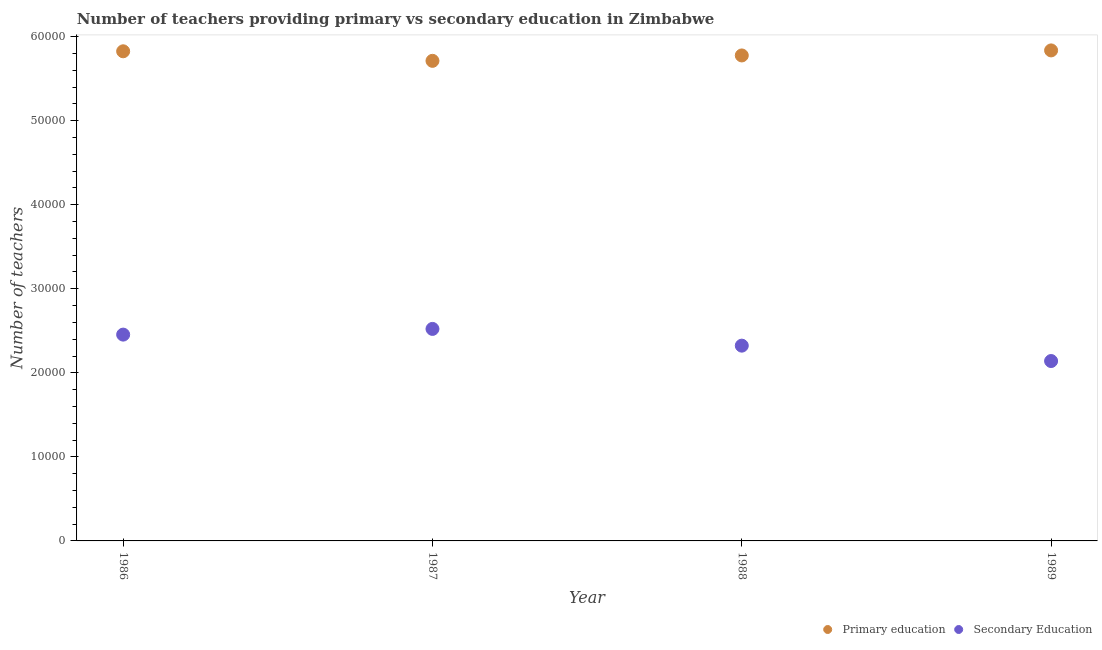How many different coloured dotlines are there?
Offer a terse response. 2. What is the number of primary teachers in 1988?
Keep it short and to the point. 5.78e+04. Across all years, what is the maximum number of secondary teachers?
Provide a short and direct response. 2.52e+04. Across all years, what is the minimum number of primary teachers?
Give a very brief answer. 5.71e+04. What is the total number of secondary teachers in the graph?
Make the answer very short. 9.44e+04. What is the difference between the number of secondary teachers in 1988 and the number of primary teachers in 1986?
Ensure brevity in your answer.  -3.50e+04. What is the average number of primary teachers per year?
Ensure brevity in your answer.  5.79e+04. In the year 1988, what is the difference between the number of primary teachers and number of secondary teachers?
Keep it short and to the point. 3.45e+04. What is the ratio of the number of secondary teachers in 1987 to that in 1988?
Provide a succinct answer. 1.09. What is the difference between the highest and the second highest number of secondary teachers?
Ensure brevity in your answer.  678. What is the difference between the highest and the lowest number of primary teachers?
Your answer should be very brief. 1242. Is the number of secondary teachers strictly less than the number of primary teachers over the years?
Provide a succinct answer. Yes. How many dotlines are there?
Provide a short and direct response. 2. How many years are there in the graph?
Your answer should be compact. 4. What is the difference between two consecutive major ticks on the Y-axis?
Provide a short and direct response. 10000. Does the graph contain grids?
Your response must be concise. No. Where does the legend appear in the graph?
Your answer should be very brief. Bottom right. How are the legend labels stacked?
Provide a short and direct response. Horizontal. What is the title of the graph?
Keep it short and to the point. Number of teachers providing primary vs secondary education in Zimbabwe. What is the label or title of the Y-axis?
Make the answer very short. Number of teachers. What is the Number of teachers in Primary education in 1986?
Offer a terse response. 5.83e+04. What is the Number of teachers in Secondary Education in 1986?
Keep it short and to the point. 2.45e+04. What is the Number of teachers in Primary education in 1987?
Your answer should be compact. 5.71e+04. What is the Number of teachers of Secondary Education in 1987?
Offer a terse response. 2.52e+04. What is the Number of teachers in Primary education in 1988?
Offer a terse response. 5.78e+04. What is the Number of teachers in Secondary Education in 1988?
Provide a succinct answer. 2.32e+04. What is the Number of teachers in Primary education in 1989?
Provide a succinct answer. 5.84e+04. What is the Number of teachers of Secondary Education in 1989?
Provide a succinct answer. 2.14e+04. Across all years, what is the maximum Number of teachers in Primary education?
Your answer should be very brief. 5.84e+04. Across all years, what is the maximum Number of teachers in Secondary Education?
Offer a terse response. 2.52e+04. Across all years, what is the minimum Number of teachers of Primary education?
Ensure brevity in your answer.  5.71e+04. Across all years, what is the minimum Number of teachers of Secondary Education?
Give a very brief answer. 2.14e+04. What is the total Number of teachers in Primary education in the graph?
Offer a very short reply. 2.32e+05. What is the total Number of teachers of Secondary Education in the graph?
Your response must be concise. 9.44e+04. What is the difference between the Number of teachers in Primary education in 1986 and that in 1987?
Provide a short and direct response. 1137. What is the difference between the Number of teachers of Secondary Education in 1986 and that in 1987?
Your answer should be very brief. -678. What is the difference between the Number of teachers of Primary education in 1986 and that in 1988?
Keep it short and to the point. 495. What is the difference between the Number of teachers of Secondary Education in 1986 and that in 1988?
Provide a succinct answer. 1314. What is the difference between the Number of teachers in Primary education in 1986 and that in 1989?
Ensure brevity in your answer.  -105. What is the difference between the Number of teachers in Secondary Education in 1986 and that in 1989?
Offer a terse response. 3144. What is the difference between the Number of teachers of Primary education in 1987 and that in 1988?
Offer a terse response. -642. What is the difference between the Number of teachers of Secondary Education in 1987 and that in 1988?
Make the answer very short. 1992. What is the difference between the Number of teachers in Primary education in 1987 and that in 1989?
Keep it short and to the point. -1242. What is the difference between the Number of teachers in Secondary Education in 1987 and that in 1989?
Your answer should be very brief. 3822. What is the difference between the Number of teachers of Primary education in 1988 and that in 1989?
Your answer should be compact. -600. What is the difference between the Number of teachers of Secondary Education in 1988 and that in 1989?
Offer a very short reply. 1830. What is the difference between the Number of teachers of Primary education in 1986 and the Number of teachers of Secondary Education in 1987?
Your answer should be compact. 3.30e+04. What is the difference between the Number of teachers in Primary education in 1986 and the Number of teachers in Secondary Education in 1988?
Your response must be concise. 3.50e+04. What is the difference between the Number of teachers in Primary education in 1986 and the Number of teachers in Secondary Education in 1989?
Provide a succinct answer. 3.69e+04. What is the difference between the Number of teachers in Primary education in 1987 and the Number of teachers in Secondary Education in 1988?
Your response must be concise. 3.39e+04. What is the difference between the Number of teachers in Primary education in 1987 and the Number of teachers in Secondary Education in 1989?
Make the answer very short. 3.57e+04. What is the difference between the Number of teachers in Primary education in 1988 and the Number of teachers in Secondary Education in 1989?
Provide a short and direct response. 3.64e+04. What is the average Number of teachers in Primary education per year?
Provide a short and direct response. 5.79e+04. What is the average Number of teachers in Secondary Education per year?
Offer a very short reply. 2.36e+04. In the year 1986, what is the difference between the Number of teachers in Primary education and Number of teachers in Secondary Education?
Your answer should be compact. 3.37e+04. In the year 1987, what is the difference between the Number of teachers in Primary education and Number of teachers in Secondary Education?
Offer a very short reply. 3.19e+04. In the year 1988, what is the difference between the Number of teachers in Primary education and Number of teachers in Secondary Education?
Give a very brief answer. 3.45e+04. In the year 1989, what is the difference between the Number of teachers of Primary education and Number of teachers of Secondary Education?
Your answer should be compact. 3.70e+04. What is the ratio of the Number of teachers in Primary education in 1986 to that in 1987?
Provide a succinct answer. 1.02. What is the ratio of the Number of teachers in Secondary Education in 1986 to that in 1987?
Keep it short and to the point. 0.97. What is the ratio of the Number of teachers in Primary education in 1986 to that in 1988?
Your response must be concise. 1.01. What is the ratio of the Number of teachers of Secondary Education in 1986 to that in 1988?
Your answer should be compact. 1.06. What is the ratio of the Number of teachers of Primary education in 1986 to that in 1989?
Ensure brevity in your answer.  1. What is the ratio of the Number of teachers in Secondary Education in 1986 to that in 1989?
Give a very brief answer. 1.15. What is the ratio of the Number of teachers in Primary education in 1987 to that in 1988?
Your answer should be very brief. 0.99. What is the ratio of the Number of teachers in Secondary Education in 1987 to that in 1988?
Keep it short and to the point. 1.09. What is the ratio of the Number of teachers of Primary education in 1987 to that in 1989?
Offer a terse response. 0.98. What is the ratio of the Number of teachers of Secondary Education in 1987 to that in 1989?
Offer a terse response. 1.18. What is the ratio of the Number of teachers of Secondary Education in 1988 to that in 1989?
Keep it short and to the point. 1.09. What is the difference between the highest and the second highest Number of teachers of Primary education?
Keep it short and to the point. 105. What is the difference between the highest and the second highest Number of teachers in Secondary Education?
Give a very brief answer. 678. What is the difference between the highest and the lowest Number of teachers in Primary education?
Your answer should be compact. 1242. What is the difference between the highest and the lowest Number of teachers in Secondary Education?
Provide a succinct answer. 3822. 